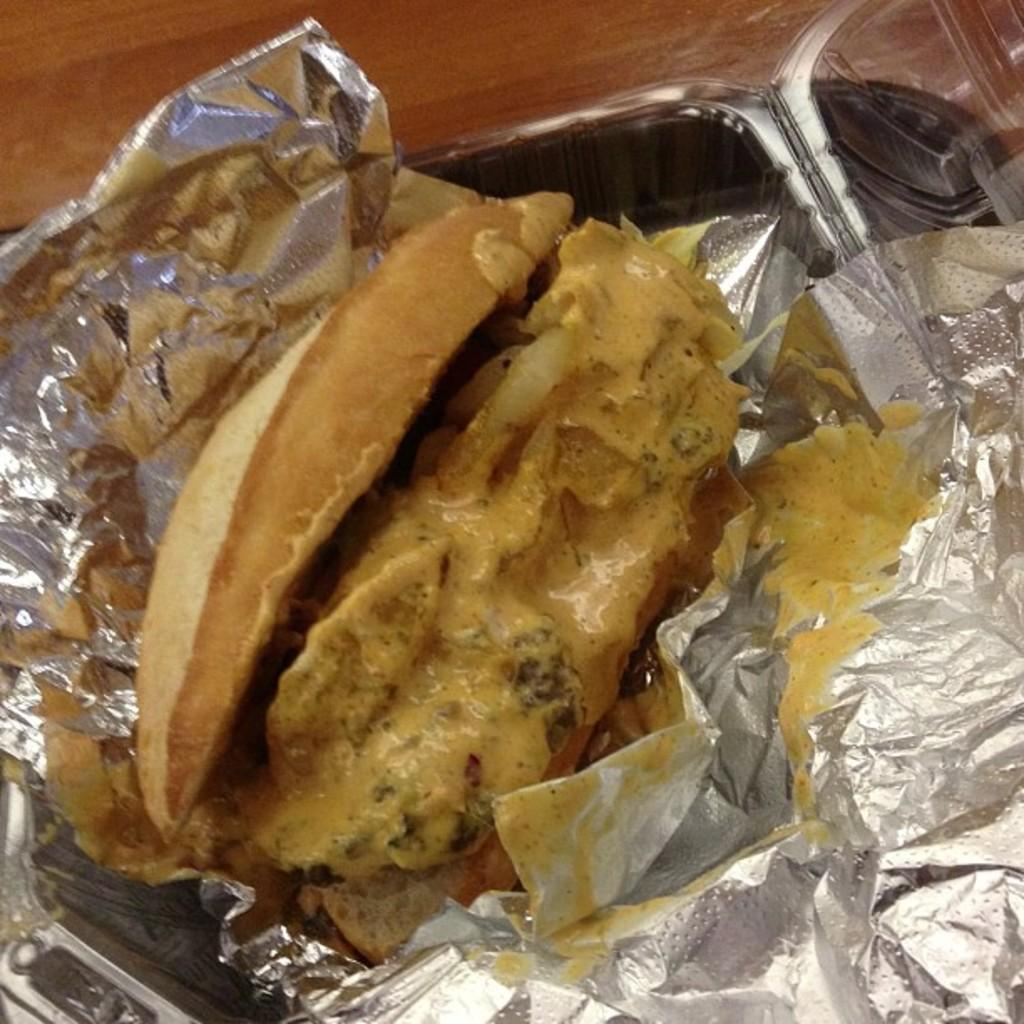What type of items are present in the image? The image contains eatables. Can you describe any containers or wrappings in the image? Yes, there is a box and aluminium foil in the image. What type of powder is sprinkled on the eatables in the image? There is no powder visible on the eatables in the image. What time of day is the image depicting, given the presence of morning light? The time of day is not mentioned or indicated in the image, so it cannot be determined. 